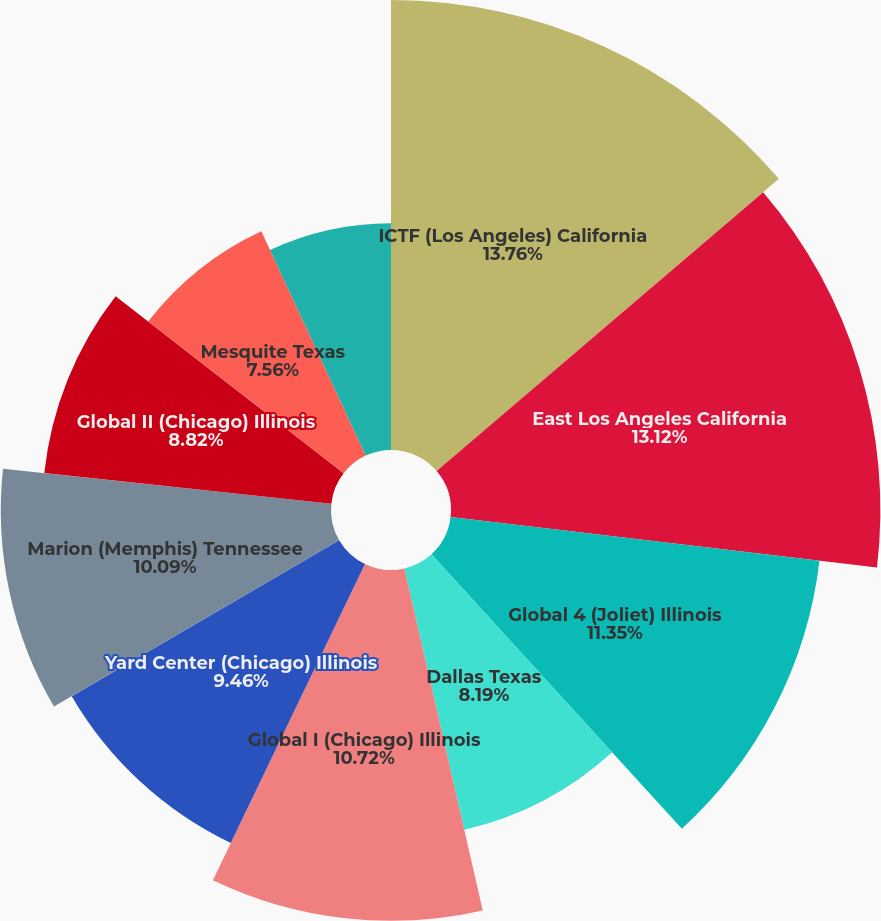Convert chart. <chart><loc_0><loc_0><loc_500><loc_500><pie_chart><fcel>ICTF (Los Angeles) California<fcel>East Los Angeles California<fcel>Global 4 (Joliet) Illinois<fcel>Dallas Texas<fcel>Global I (Chicago) Illinois<fcel>Yard Center (Chicago) Illinois<fcel>Marion (Memphis) Tennessee<fcel>Global II (Chicago) Illinois<fcel>Mesquite Texas<fcel>LATC (Los Angeles) California<nl><fcel>13.75%<fcel>13.12%<fcel>11.35%<fcel>8.19%<fcel>10.72%<fcel>9.46%<fcel>10.09%<fcel>8.82%<fcel>7.56%<fcel>6.93%<nl></chart> 